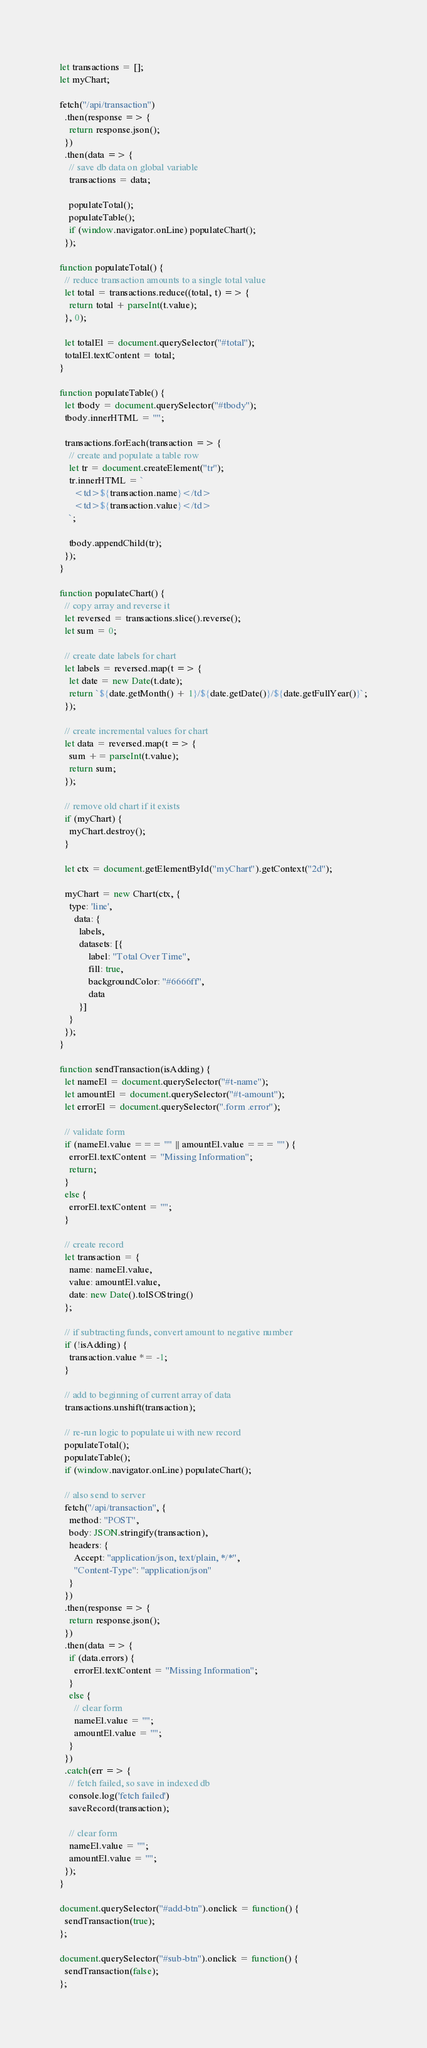Convert code to text. <code><loc_0><loc_0><loc_500><loc_500><_JavaScript_>let transactions = [];
let myChart;

fetch("/api/transaction")
  .then(response => {
    return response.json();
  })
  .then(data => {
    // save db data on global variable
    transactions = data;

    populateTotal();
    populateTable();
    if (window.navigator.onLine) populateChart();
  });

function populateTotal() {
  // reduce transaction amounts to a single total value
  let total = transactions.reduce((total, t) => {
    return total + parseInt(t.value);
  }, 0);

  let totalEl = document.querySelector("#total");
  totalEl.textContent = total;
}

function populateTable() {
  let tbody = document.querySelector("#tbody");
  tbody.innerHTML = "";

  transactions.forEach(transaction => {
    // create and populate a table row
    let tr = document.createElement("tr");
    tr.innerHTML = `
      <td>${transaction.name}</td>
      <td>${transaction.value}</td>
    `;

    tbody.appendChild(tr);
  });
}

function populateChart() {
  // copy array and reverse it
  let reversed = transactions.slice().reverse();
  let sum = 0;

  // create date labels for chart
  let labels = reversed.map(t => {
    let date = new Date(t.date);
    return `${date.getMonth() + 1}/${date.getDate()}/${date.getFullYear()}`;
  });

  // create incremental values for chart
  let data = reversed.map(t => {
    sum += parseInt(t.value);
    return sum;
  });

  // remove old chart if it exists
  if (myChart) {
    myChart.destroy();
  }

  let ctx = document.getElementById("myChart").getContext("2d");

  myChart = new Chart(ctx, {
    type: 'line',
      data: {
        labels,
        datasets: [{
            label: "Total Over Time",
            fill: true,
            backgroundColor: "#6666ff",
            data
        }]
    }
  });
}

function sendTransaction(isAdding) {
  let nameEl = document.querySelector("#t-name");
  let amountEl = document.querySelector("#t-amount");
  let errorEl = document.querySelector(".form .error");

  // validate form
  if (nameEl.value === "" || amountEl.value === "") {
    errorEl.textContent = "Missing Information";
    return;
  }
  else {
    errorEl.textContent = "";
  }

  // create record
  let transaction = {
    name: nameEl.value,
    value: amountEl.value,
    date: new Date().toISOString()
  };

  // if subtracting funds, convert amount to negative number
  if (!isAdding) {
    transaction.value *= -1;
  }

  // add to beginning of current array of data
  transactions.unshift(transaction);

  // re-run logic to populate ui with new record
  populateTotal();
  populateTable();
  if (window.navigator.onLine) populateChart();

  // also send to server
  fetch("/api/transaction", {
    method: "POST",
    body: JSON.stringify(transaction),
    headers: {
      Accept: "application/json, text/plain, */*",
      "Content-Type": "application/json"
    }
  })
  .then(response => {
    return response.json();
  })
  .then(data => {
    if (data.errors) {
      errorEl.textContent = "Missing Information";
    }
    else {
      // clear form
      nameEl.value = "";
      amountEl.value = "";
    }
  })
  .catch(err => {
    // fetch failed, so save in indexed db
    console.log('fetch failed')
    saveRecord(transaction);

    // clear form
    nameEl.value = "";
    amountEl.value = "";
  });
}

document.querySelector("#add-btn").onclick = function() {
  sendTransaction(true);
};

document.querySelector("#sub-btn").onclick = function() {
  sendTransaction(false);
};
</code> 